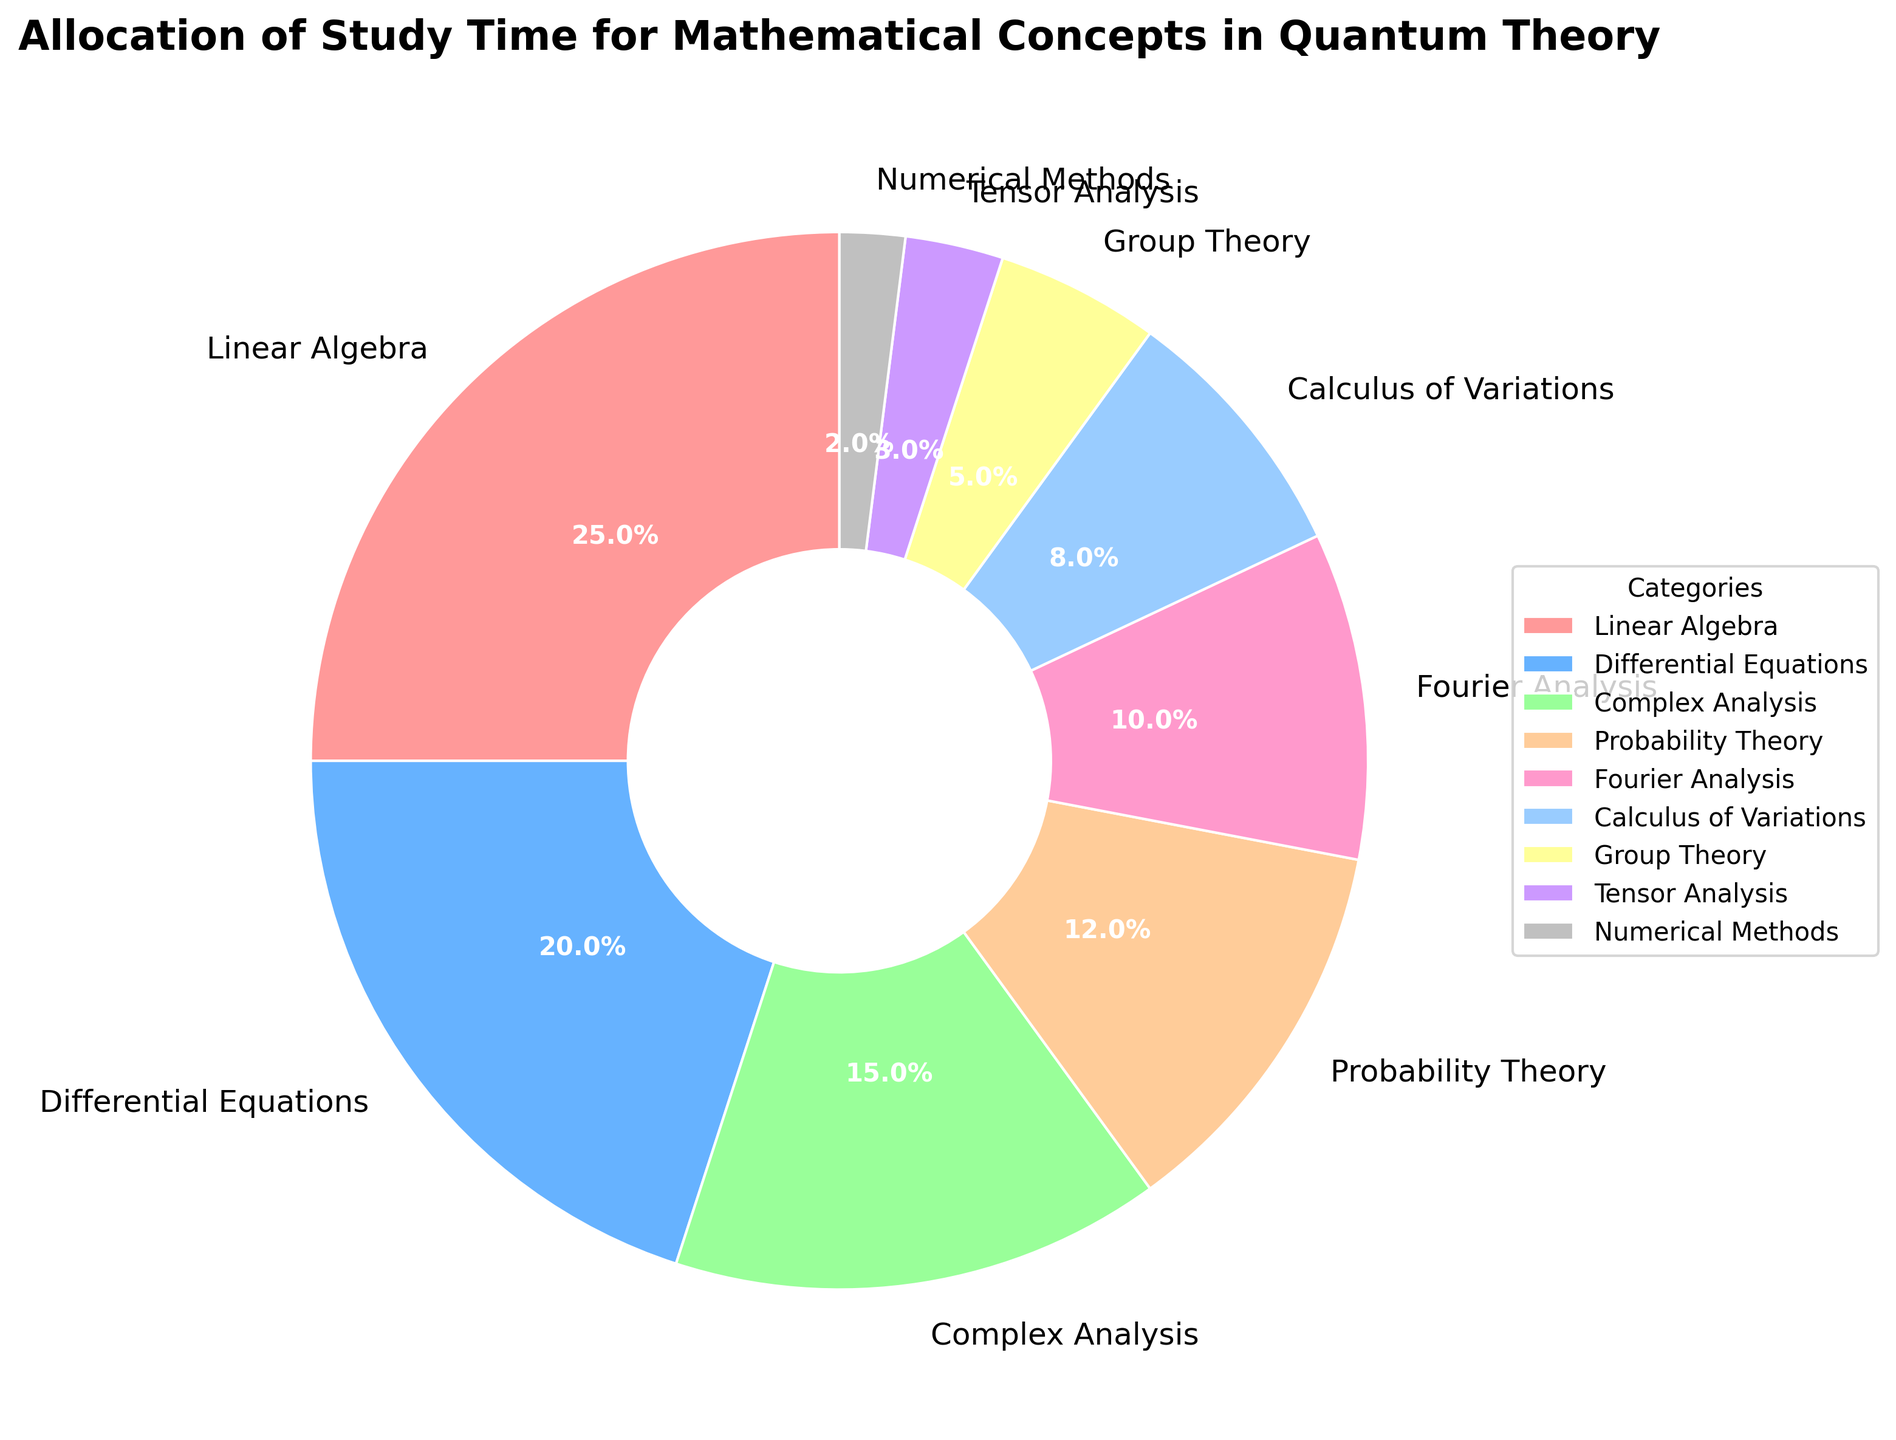What's the sum of the percentages for Linear Algebra and Differential Equations? The percentage of study time allocated to Linear Algebra is 25%, and for Differential Equations, it is 20%. Adding these two gives 25% + 20% = 45%.
Answer: 45% Which category has the smallest allocation of study time? The category with the smallest slice in the pie chart corresponds to Numerical Methods, which has a percentage of 2%.
Answer: Numerical Methods Is the allocation of study time for Probability Theory greater than that for Fourier Analysis? The percentage for Probability Theory is 12%, while for Fourier Analysis it is 10%. Since 12% > 10%, the allocation for Probability Theory is greater.
Answer: Yes What is the difference in the time allocation between Complex Analysis and Group Theory? The percentage allocated to Complex Analysis is 15%, and to Group Theory, it is 5%. The difference is 15% - 5% = 10%.
Answer: 10% Identify the category with a color similar to pale blue in the chart. The category represented by a pale blue color in the pie chart is Differential Equations.
Answer: Differential Equations What is the combined percentage for the categories with the lowest three allocations? The categories with the lowest three allocations are Tensor Analysis (3%), Numerical Methods (2%), and Group Theory (5%). Summing these gives 3% + 2% + 5% = 10%.
Answer: 10% Which category appears as the second largest slice in the pie chart? The second largest slice corresponds to Differential Equations, which has a 20% allocation.
Answer: Differential Equations How much more study time is allocated to Calculus of Variations compared to Tensor Analysis? Calculus of Variations is allocated 8%, while Tensor Analysis is allocated 3%. The difference is 8% - 3% = 5%.
Answer: 5% How many categories have an allocation greater than 10%? The categories with allocations greater than 10% are Linear Algebra (25%), Differential Equations (20%), Complex Analysis (15%), Probability Theory (12%), and Fourier Analysis (10%). There are 4 categories in total.
Answer: 4 